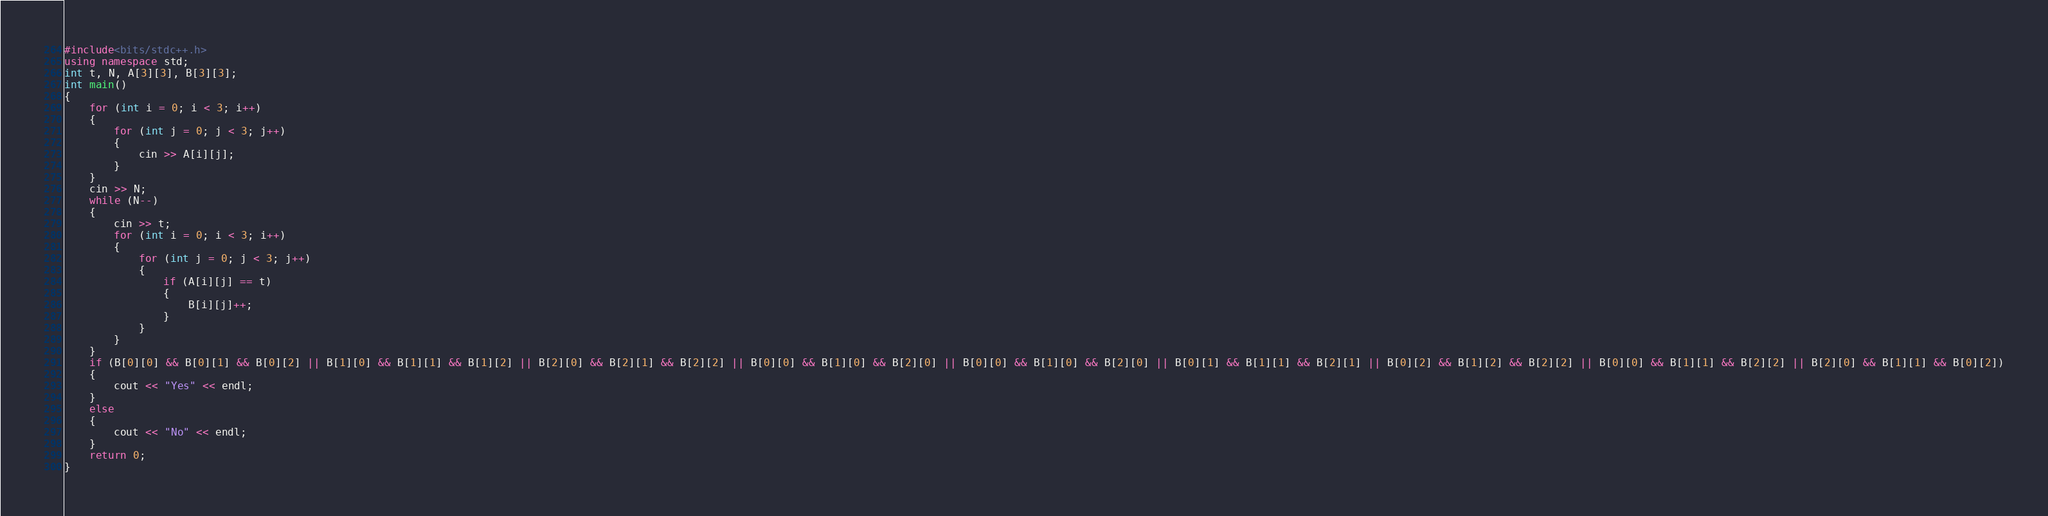Convert code to text. <code><loc_0><loc_0><loc_500><loc_500><_C++_>#include<bits/stdc++.h>
using namespace std;
int t, N, A[3][3], B[3][3];
int main()
{
	for (int i = 0; i < 3; i++)
	{
		for (int j = 0; j < 3; j++)
		{
			cin >> A[i][j];
		}
	}
	cin >> N;
	while (N--)
	{
		cin >> t;
		for (int i = 0; i < 3; i++)
		{
			for (int j = 0; j < 3; j++)
			{
				if (A[i][j] == t)
				{
					B[i][j]++;
				}
			}
		}
	}
	if (B[0][0] && B[0][1] && B[0][2] || B[1][0] && B[1][1] && B[1][2] || B[2][0] && B[2][1] && B[2][2] || B[0][0] && B[1][0] && B[2][0] || B[0][0] && B[1][0] && B[2][0] || B[0][1] && B[1][1] && B[2][1] || B[0][2] && B[1][2] && B[2][2] || B[0][0] && B[1][1] && B[2][2] || B[2][0] && B[1][1] && B[0][2])
	{
		cout << "Yes" << endl;
	}
	else
	{
		cout << "No" << endl;
	}
	return 0;
}
</code> 